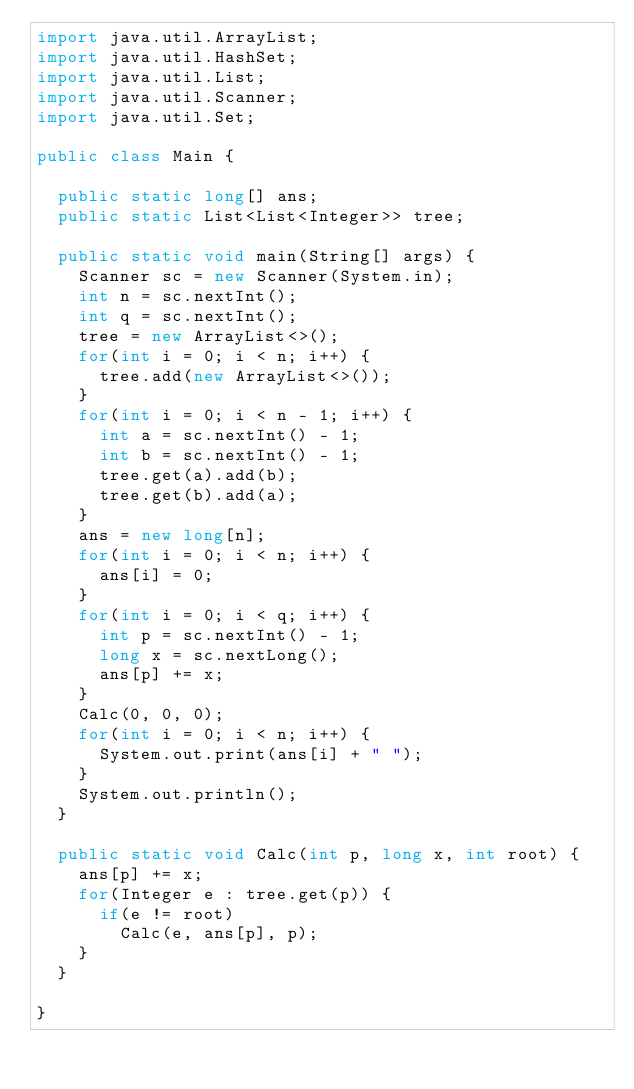<code> <loc_0><loc_0><loc_500><loc_500><_Java_>import java.util.ArrayList;
import java.util.HashSet;
import java.util.List;
import java.util.Scanner;
import java.util.Set;

public class Main {

	public static long[] ans;
	public static List<List<Integer>> tree;

	public static void main(String[] args) {
		Scanner sc = new Scanner(System.in);
		int n = sc.nextInt();
		int q = sc.nextInt();
		tree = new ArrayList<>();
		for(int i = 0; i < n; i++) {
			tree.add(new ArrayList<>());
		}
		for(int i = 0; i < n - 1; i++) {
			int a = sc.nextInt() - 1;
			int b = sc.nextInt() - 1;
			tree.get(a).add(b);
			tree.get(b).add(a);
		}
		ans = new long[n];
		for(int i = 0; i < n; i++) {
			ans[i] = 0;
		}
		for(int i = 0; i < q; i++) {
			int p = sc.nextInt() - 1;
			long x = sc.nextLong();
			ans[p] += x;
		}
		Calc(0, 0, 0);
		for(int i = 0; i < n; i++) {
			System.out.print(ans[i] + " ");
		}
		System.out.println();
	}

	public static void Calc(int p, long x, int root) {
		ans[p] += x;
		for(Integer e : tree.get(p)) {
			if(e != root)
				Calc(e, ans[p], p);
		}
	}

}
</code> 